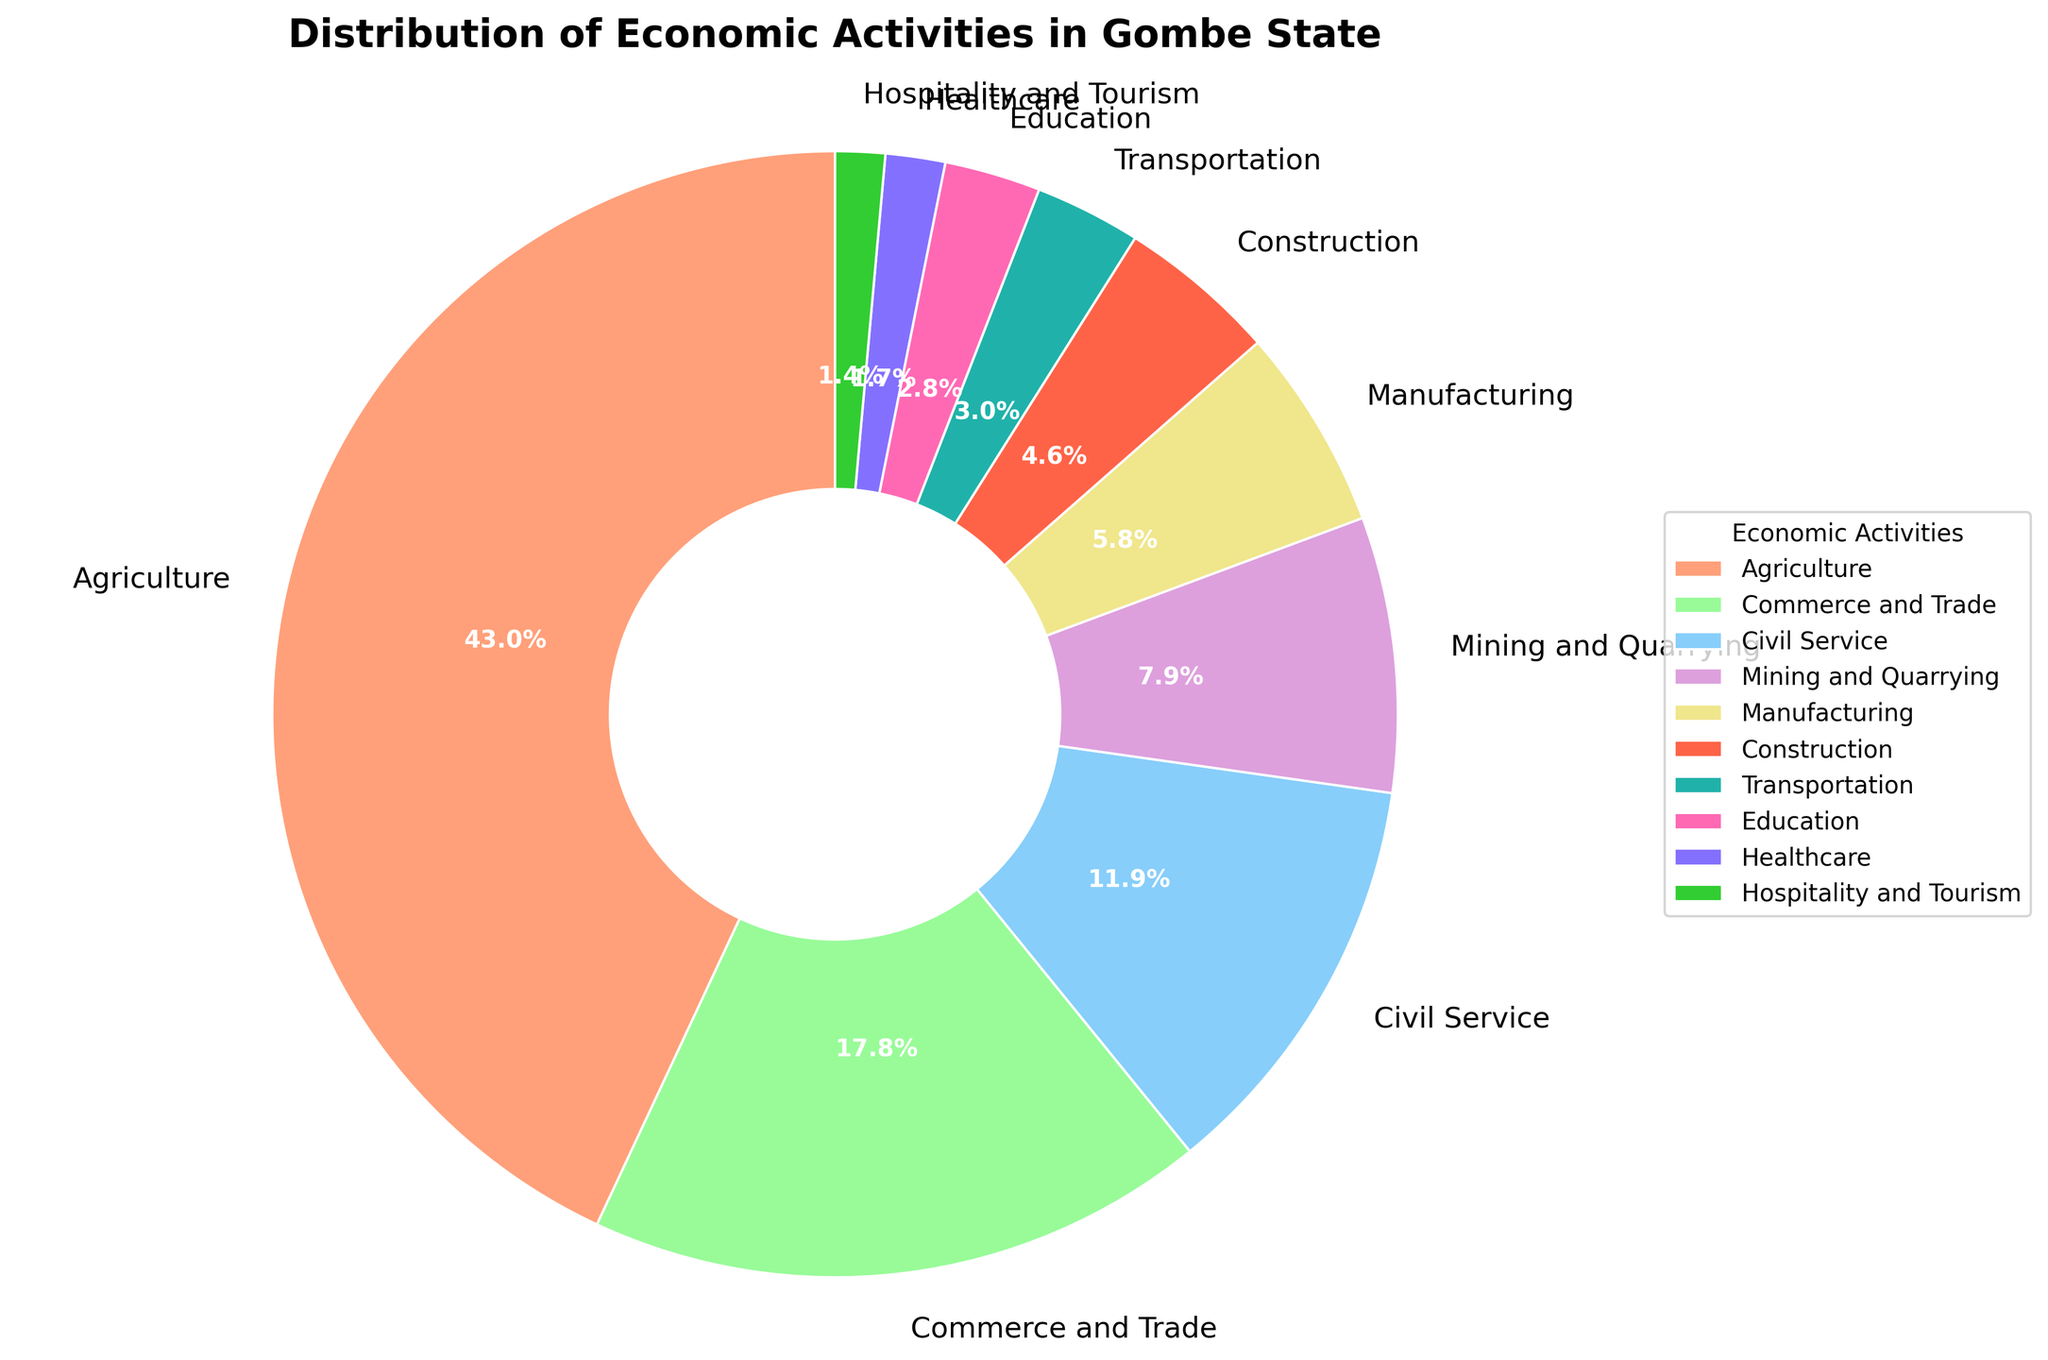What economic activity holds the largest share in Gombe State's economy? The pie chart shows the largest sector by the size of the slice it occupies. The largest slice corresponds to Agriculture, which has a percentage of 45.2%.
Answer: Agriculture Which economic activity has a percentage closest to 20%? By looking at the percentages and the slices, Commerce and Trade has a percentage of 18.7%, which is the closest to 20%.
Answer: Commerce and Trade What is the combined percentage of Agriculture, Commerce and Trade, and Civil Service? The percentages for Agriculture, Commerce and Trade, and Civil Service are 45.2%, 18.7%, and 12.5% respectively. Adding them together, 45.2 + 18.7 + 12.5 = 76.4%.
Answer: 76.4% Are there more economic activities with percentages greater than 10% or less than 10%? Activities with percentages greater than 10% are Agriculture (45.2%), Commerce and Trade (18.7%), and Civil Service (12.5%). There are 3 slices greater than 10%. Activities with less than 10% are Mining and Quarrying (8.3%), Manufacturing (6.1%), Construction (4.8%), Transportation (3.2%), Education (2.9%), Healthcare (1.8%), and Hospitality and Tourism (1.5%). There are 7 slices less than 10%.
Answer: Less than 10% Which economic activity corresponds to the green-colored slice in the chart? By observing the visual attributes of the pie chart, the green-colored slice corresponds to the percentage associated with Commerce and Trade.
Answer: Commerce and Trade How much larger is the Agriculture slice compared to the Manufacturing slice? The percentage for Agriculture is 45.2% and for Manufacturing is 6.1%. Subtracting these percentages, 45.2 - 6.1 = 39.1%.
Answer: 39.1% Is the percentage of Mining and Quarrying greater than that of Construction and Transportation combined? The percentage for Mining and Quarrying is 8.3%. The percentages for Construction and Transportation are 4.8% and 3.2% respectively. Adding these together, 4.8 + 3.2 = 8.0%, which is less than 8.3%.
Answer: Yes What percentage of the economy is represented by sectors other than Agriculture, Commerce and Trade, and Civil Service? The combined percentage of Agriculture, Commerce and Trade, and Civil Service is 76.4%. Subtracting this from 100%, 100 - 76.4 = 23.6%.
Answer: 23.6% Which economic activity has the smallest share in Gombe State's economy? The smallest slice corresponds to the sector with the least percentage. Hospitality and Tourism has the smallest share with 1.5%.
Answer: Hospitality and Tourism How many sectors have a share of less than 5%? From the chart, Construction (4.8%), Transportation (3.2%), Education (2.9%), Healthcare (1.8%), and Hospitality and Tourism (1.5%) are the slices with less than 5%. There are 5 such sectors.
Answer: 5 